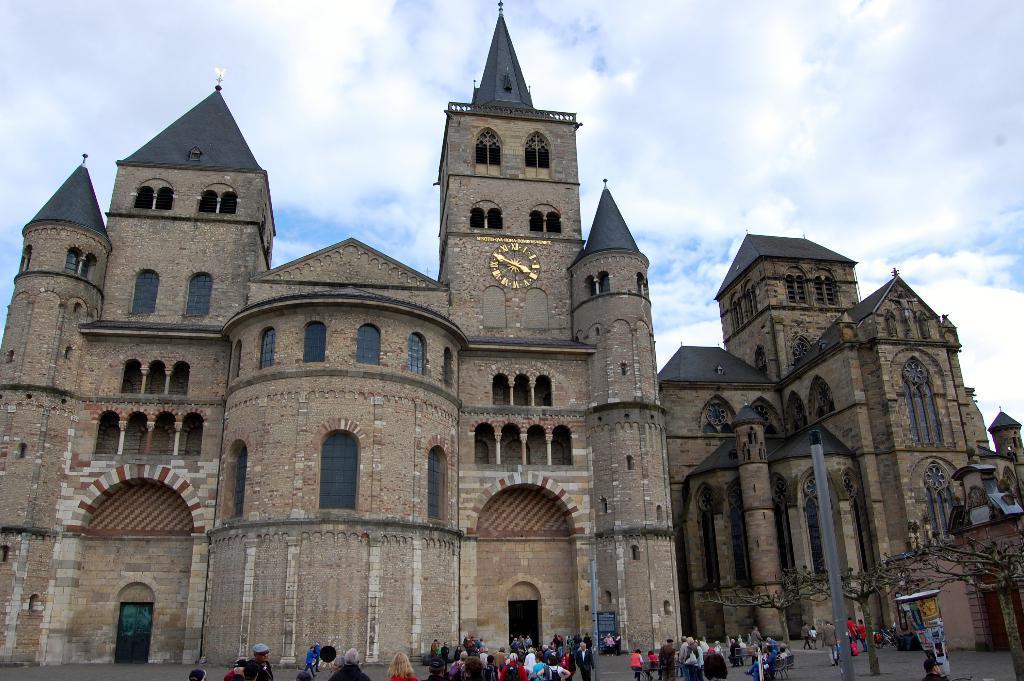Please provide a concise description of this image. In this image I can see few persons are standing on the ground, a huge pole, few trees and few buildings which are brown and black in color. I can see a clock which is gold in color to the building. In the background I can see the sky. 